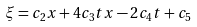Convert formula to latex. <formula><loc_0><loc_0><loc_500><loc_500>\xi = c _ { 2 } x + 4 c _ { 3 } t x - 2 c _ { 4 } t + c _ { 5 }</formula> 